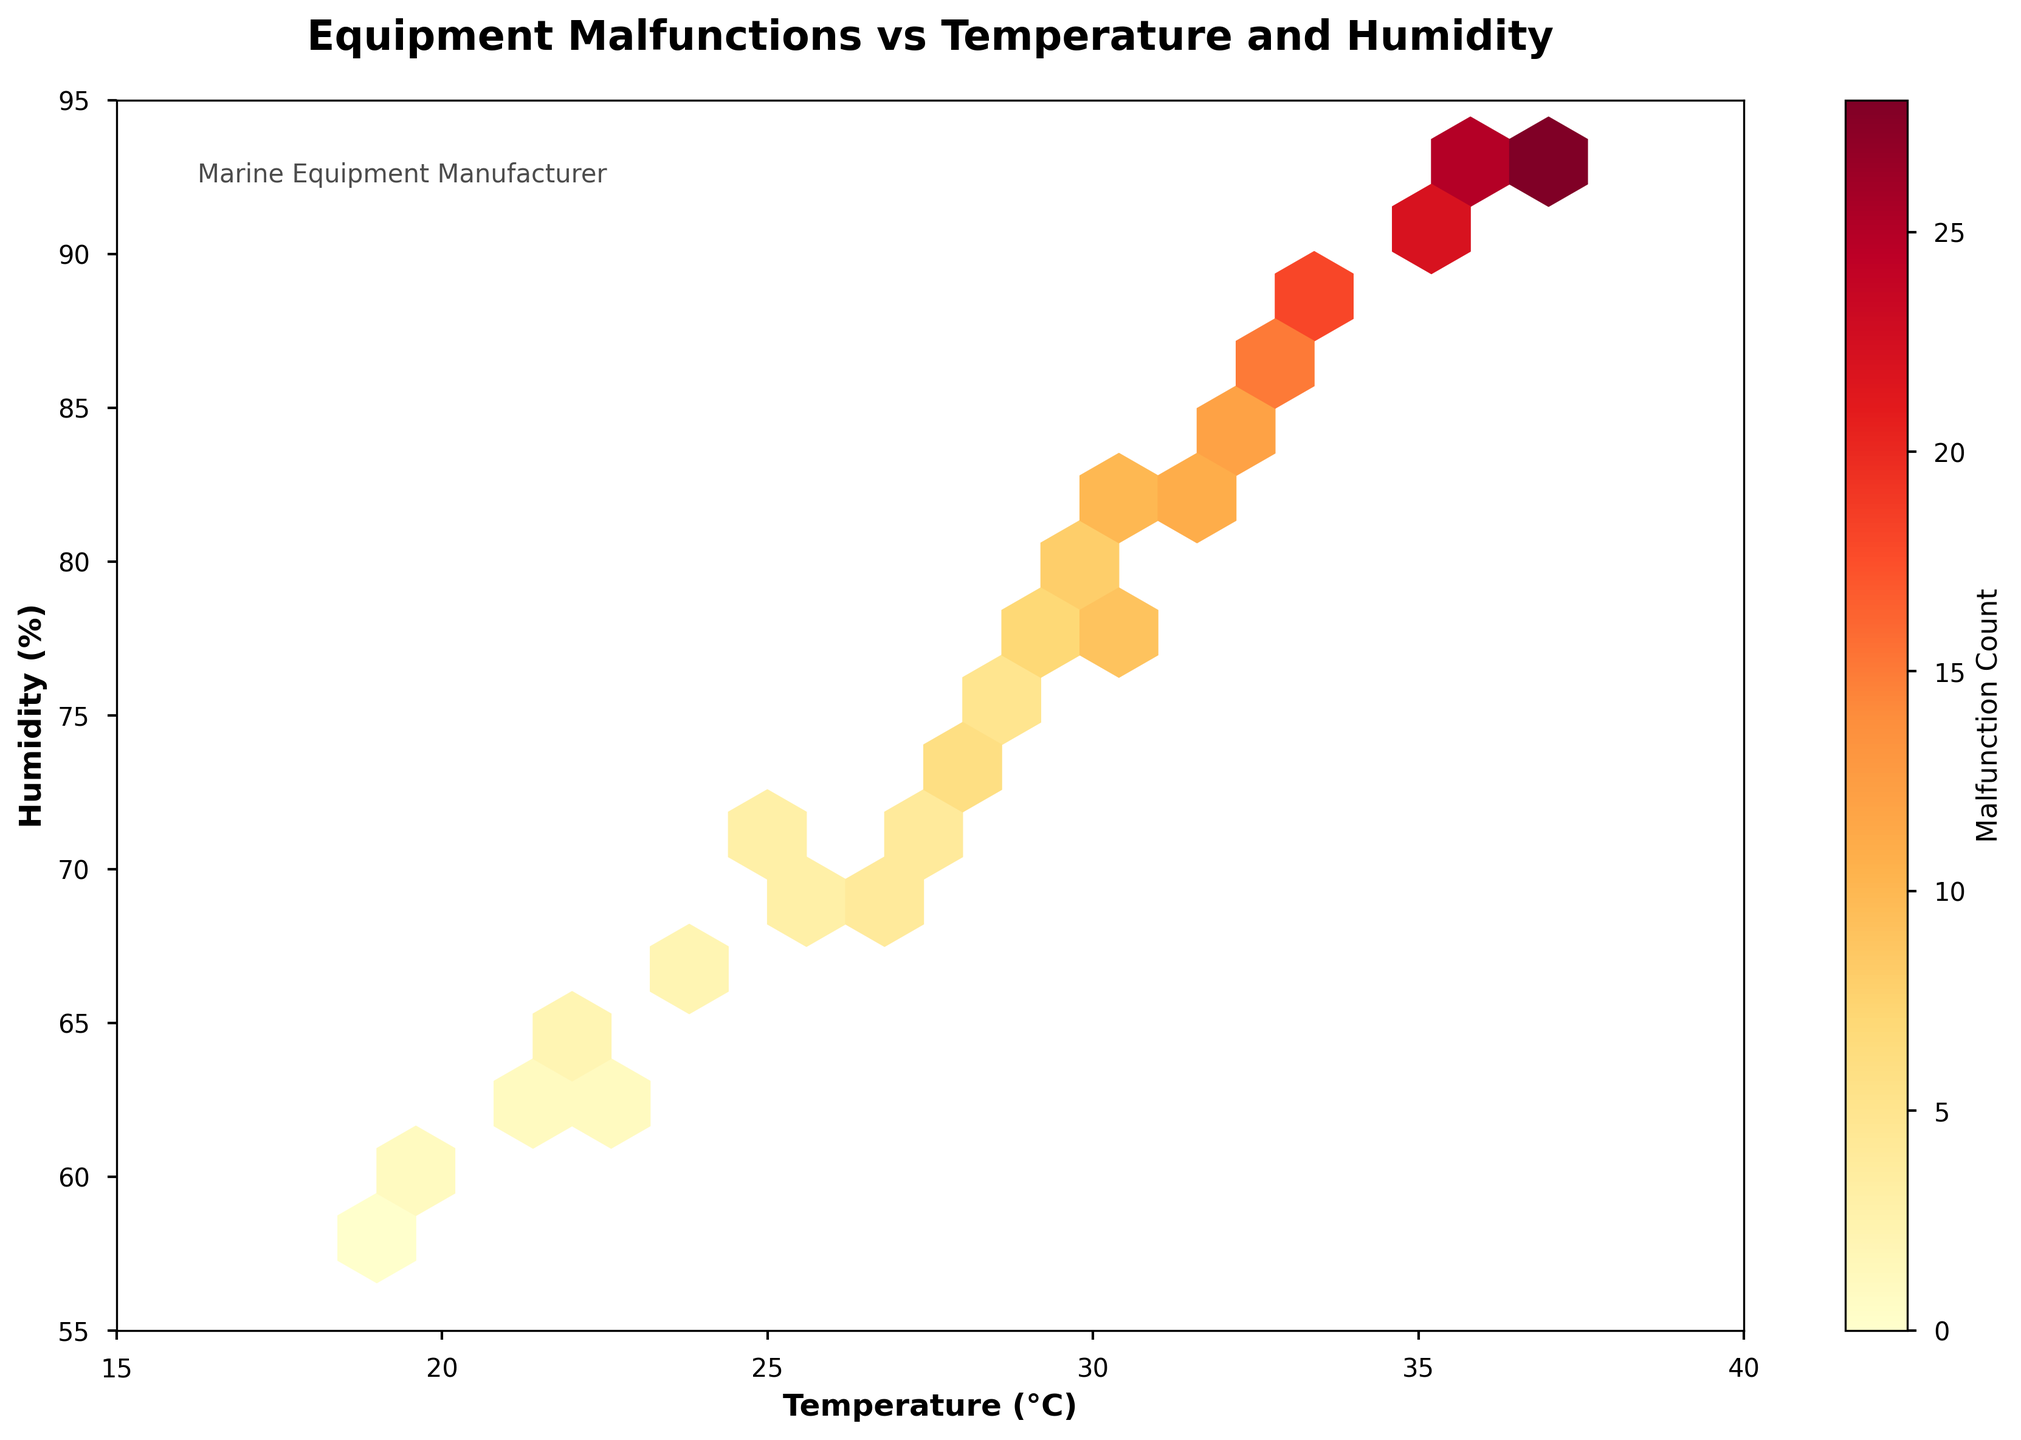What is the title of the plot? The title appears at the top of the plot and summarizes the content of the graph.
Answer: Equipment Malfunctions vs Temperature and Humidity What does the color intensity represent in this plot? Color intensity represents the count of malfunctions, as indicated by the color bar labeled 'Malfunction Count'.
Answer: Malfunction Count What are the axis labels on this plot? The x-axis is labeled 'Temperature (°C)' and the y-axis is labeled 'Humidity (%)'.
Answer: Temperature (°C) and Humidity (%) Which region tends to have the highest occurrence of malfunctions? The region in the plot with the highest color intensity (darkest red) indicates the highest occurrence of malfunctions. This is where both temperature and humidity are higher.
Answer: High temperature and high humidity Is there any region where malfunctions are very rare or do not occur at all? The areas with the lowest color intensity (lightest yellow or no color) indicate low or no malfunctions, which seems to be at the lower temperature and humidity levels.
Answer: Low temperature and low humidity How does the malfunction count change as the temperature increases from 20°C to 35°C while keeping humidity constant around 70-75%? By observing the color intensity change along the specified temperature range, the malfunction count increases as the temperature rises from a lighter to a darker shade.
Answer: Increases Compare malfunction counts at 30°C and 28°C with similar humidity levels around 75-80%. Which has a higher count? By comparing the color intensity at 30°C and 28°C within similar humidity ranges, 30°C has a darker shade, indicating a higher malfunction count.
Answer: 30°C What is the observed malfunction count trend as humidity increases from 60% to 90% at a constant temperature of around 32°C? Following the color change along this humidity range shows an increase in malfunction counts as humidity rises, as it goes from a lighter to a darker shade.
Answer: Increases Does the plot suggest any specific temperature and humidity range that should be avoided to minimize equipment malfunctions? By identifying the darkest regions on the plot, higher temperatures (above 30°C) and high humidity levels (above 80%) should be avoided to minimize malfunctions.
Answer: Above 30°C and 80% humidity What can be inferred about areas with intermediate temperatures (25-30°C) and intermediate humidity levels (65-75%) in terms of malfunction counts? Observing the color intensity in these regions suggests that malfunction counts are moderate, with average shades indicating neither very high nor very low counts.
Answer: Moderate 